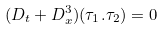Convert formula to latex. <formula><loc_0><loc_0><loc_500><loc_500>( { D } _ { t } + { D } ^ { 3 } _ { x } ) ( \tau _ { 1 } . \tau _ { 2 } ) = 0</formula> 